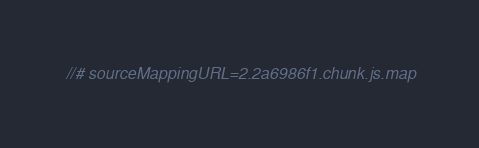<code> <loc_0><loc_0><loc_500><loc_500><_JavaScript_>//# sourceMappingURL=2.2a6986f1.chunk.js.map</code> 